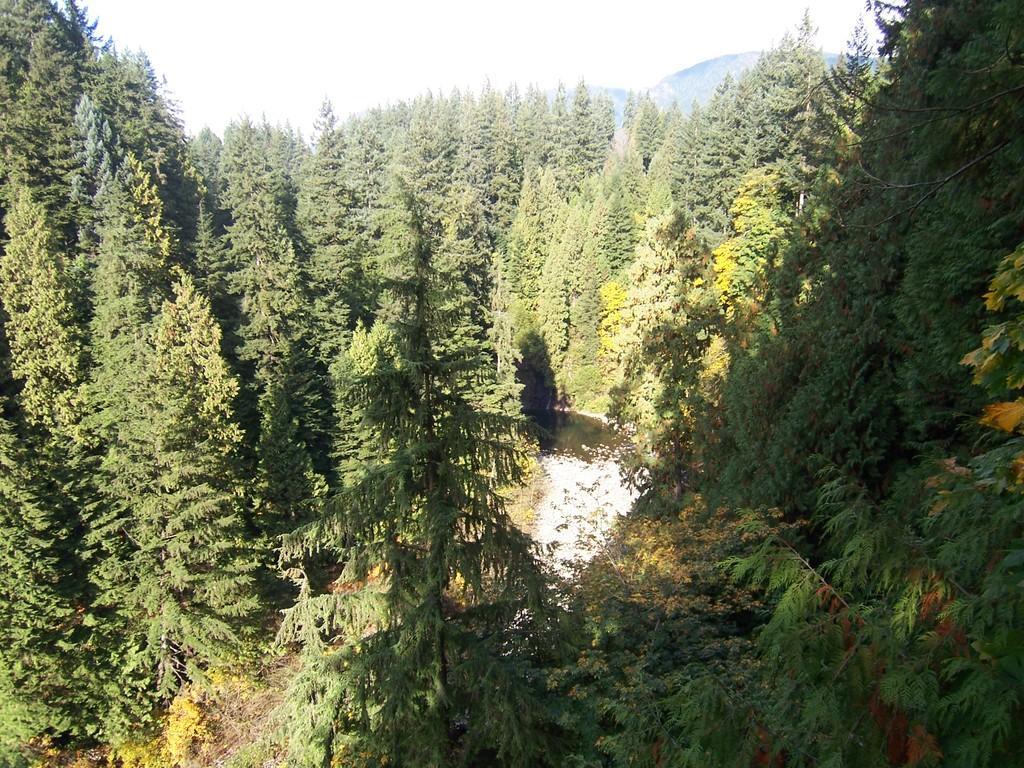Can you describe this image briefly? In this image there are people. In the center we can see a canal. At the top there is sky and we can see hills. 